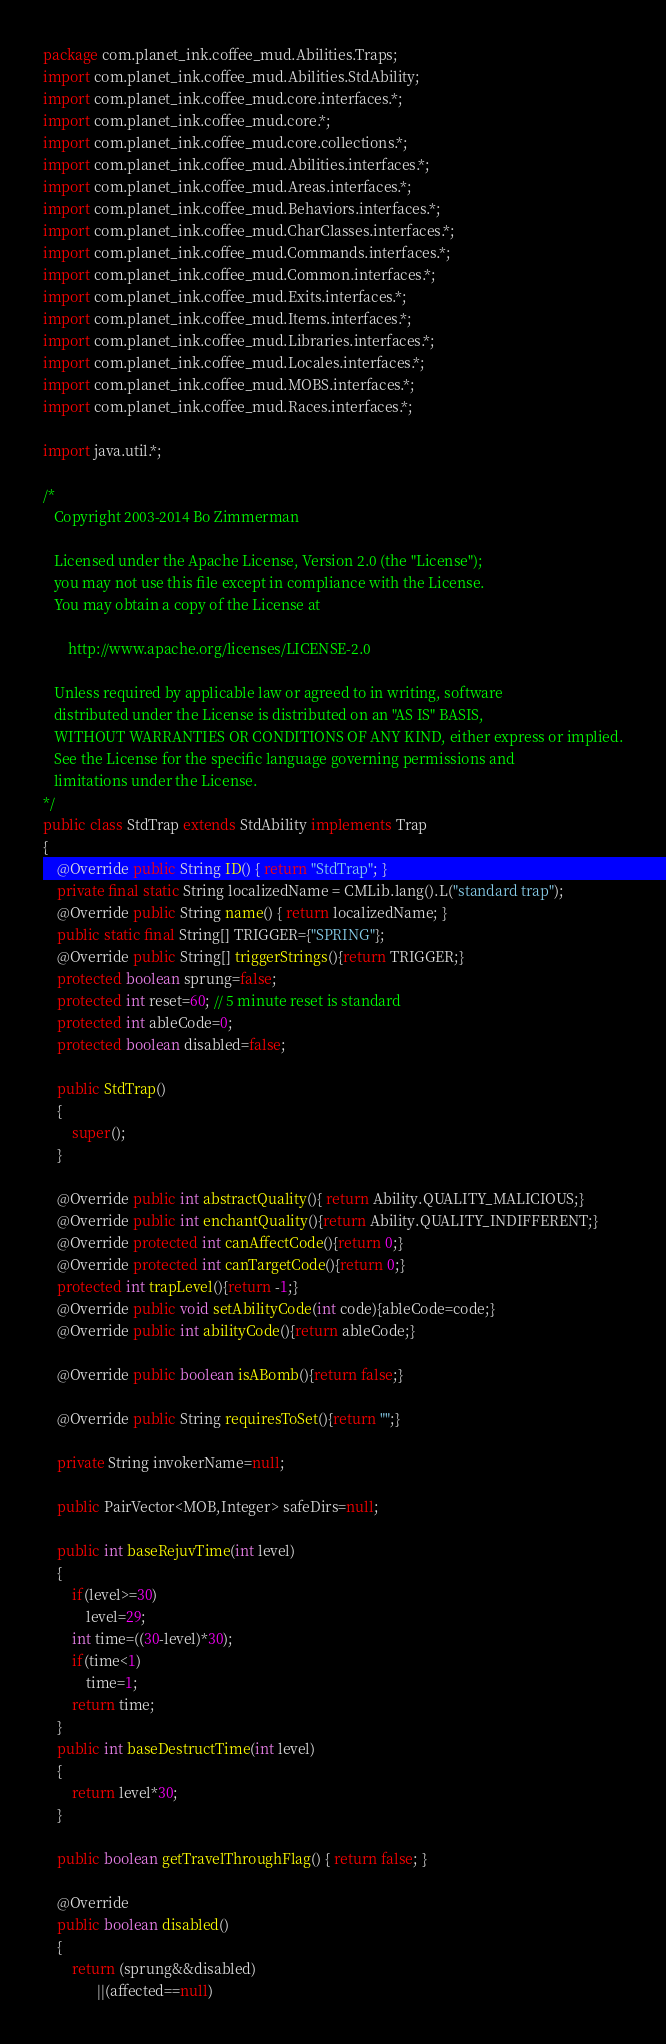Convert code to text. <code><loc_0><loc_0><loc_500><loc_500><_Java_>package com.planet_ink.coffee_mud.Abilities.Traps;
import com.planet_ink.coffee_mud.Abilities.StdAbility;
import com.planet_ink.coffee_mud.core.interfaces.*;
import com.planet_ink.coffee_mud.core.*;
import com.planet_ink.coffee_mud.core.collections.*;
import com.planet_ink.coffee_mud.Abilities.interfaces.*;
import com.planet_ink.coffee_mud.Areas.interfaces.*;
import com.planet_ink.coffee_mud.Behaviors.interfaces.*;
import com.planet_ink.coffee_mud.CharClasses.interfaces.*;
import com.planet_ink.coffee_mud.Commands.interfaces.*;
import com.planet_ink.coffee_mud.Common.interfaces.*;
import com.planet_ink.coffee_mud.Exits.interfaces.*;
import com.planet_ink.coffee_mud.Items.interfaces.*;
import com.planet_ink.coffee_mud.Libraries.interfaces.*;
import com.planet_ink.coffee_mud.Locales.interfaces.*;
import com.planet_ink.coffee_mud.MOBS.interfaces.*;
import com.planet_ink.coffee_mud.Races.interfaces.*;

import java.util.*;

/*
   Copyright 2003-2014 Bo Zimmerman

   Licensed under the Apache License, Version 2.0 (the "License");
   you may not use this file except in compliance with the License.
   You may obtain a copy of the License at

	   http://www.apache.org/licenses/LICENSE-2.0

   Unless required by applicable law or agreed to in writing, software
   distributed under the License is distributed on an "AS IS" BASIS,
   WITHOUT WARRANTIES OR CONDITIONS OF ANY KIND, either express or implied.
   See the License for the specific language governing permissions and
   limitations under the License.
*/
public class StdTrap extends StdAbility implements Trap
{
	@Override public String ID() { return "StdTrap"; }
	private final static String localizedName = CMLib.lang().L("standard trap");
	@Override public String name() { return localizedName; }
	public static final String[] TRIGGER={"SPRING"};
	@Override public String[] triggerStrings(){return TRIGGER;}
	protected boolean sprung=false;
	protected int reset=60; // 5 minute reset is standard
	protected int ableCode=0;
	protected boolean disabled=false;

	public StdTrap()
	{
		super();
	}

	@Override public int abstractQuality(){ return Ability.QUALITY_MALICIOUS;}
	@Override public int enchantQuality(){return Ability.QUALITY_INDIFFERENT;}
	@Override protected int canAffectCode(){return 0;}
	@Override protected int canTargetCode(){return 0;}
	protected int trapLevel(){return -1;}
	@Override public void setAbilityCode(int code){ableCode=code;}
	@Override public int abilityCode(){return ableCode;}

	@Override public boolean isABomb(){return false;}

	@Override public String requiresToSet(){return "";}

	private String invokerName=null;

	public PairVector<MOB,Integer> safeDirs=null;

	public int baseRejuvTime(int level)
	{
		if(level>=30)
			level=29;
		int time=((30-level)*30);
		if(time<1)
			time=1;
		return time;
	}
	public int baseDestructTime(int level)
	{
		return level*30;
	}

	public boolean getTravelThroughFlag() { return false; }

	@Override
	public boolean disabled()
	{
		return (sprung&&disabled)
			   ||(affected==null)</code> 